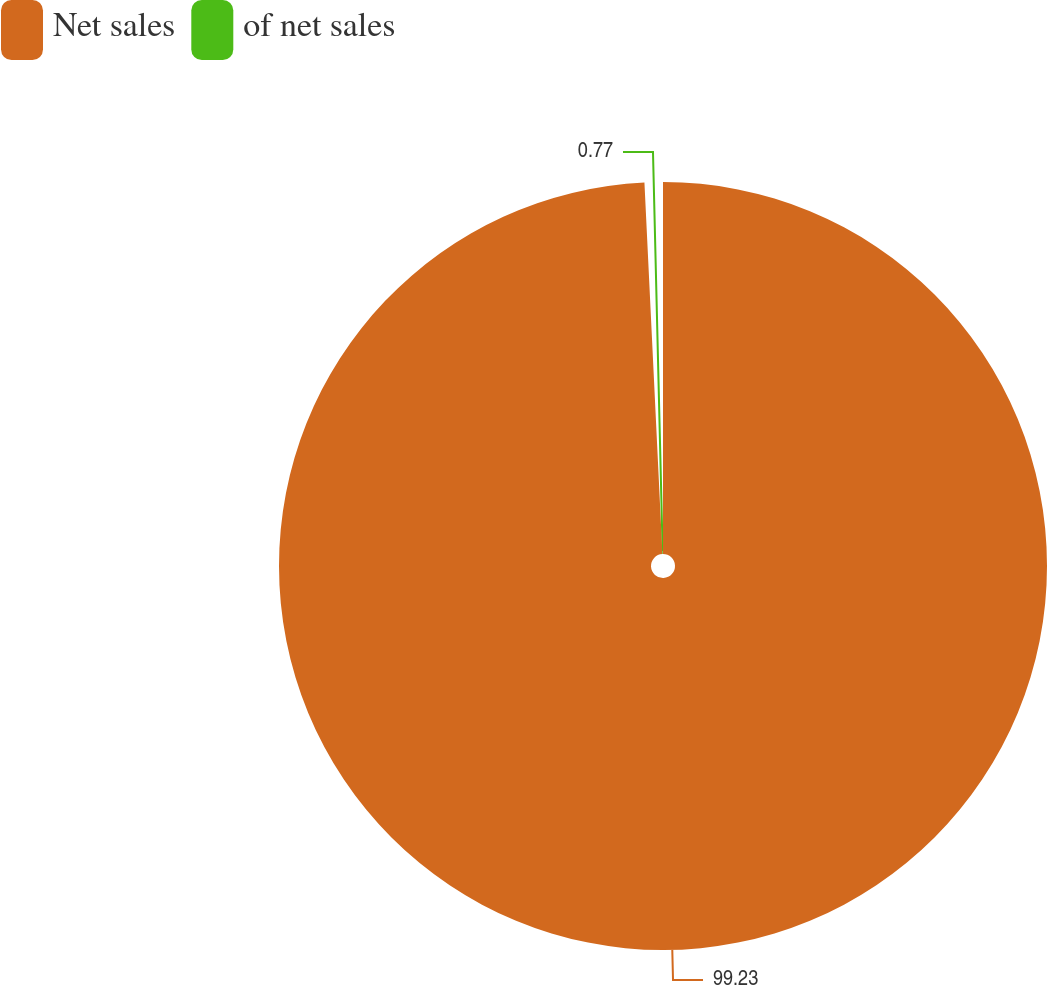Convert chart. <chart><loc_0><loc_0><loc_500><loc_500><pie_chart><fcel>Net sales<fcel>of net sales<nl><fcel>99.23%<fcel>0.77%<nl></chart> 